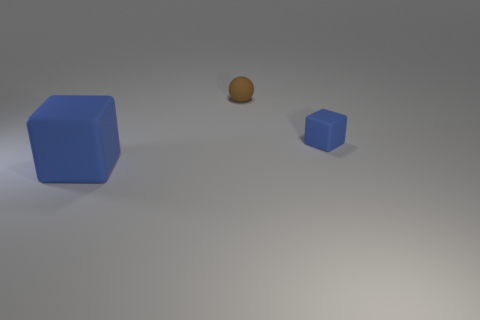What color is the tiny rubber thing that is in front of the small sphere?
Provide a short and direct response. Blue. There is a small brown sphere left of the small matte thing that is in front of the rubber sphere; what is it made of?
Offer a very short reply. Rubber. Is there a blue rubber block of the same size as the brown matte ball?
Provide a succinct answer. Yes. How many things are either big cubes left of the small block or blue rubber objects behind the big blue matte object?
Provide a succinct answer. 2. Do the blue block that is in front of the tiny block and the object that is behind the small blue rubber object have the same size?
Your response must be concise. No. There is a matte block that is behind the big blue cube; is there a thing that is in front of it?
Ensure brevity in your answer.  Yes. What number of tiny blue objects are in front of the brown rubber thing?
Give a very brief answer. 1. How many other things are the same color as the small matte ball?
Provide a succinct answer. 0. Are there fewer tiny blue things in front of the large blue matte thing than matte cubes in front of the brown matte thing?
Offer a terse response. Yes. What number of objects are either things in front of the brown rubber object or tiny matte things?
Offer a very short reply. 3. 